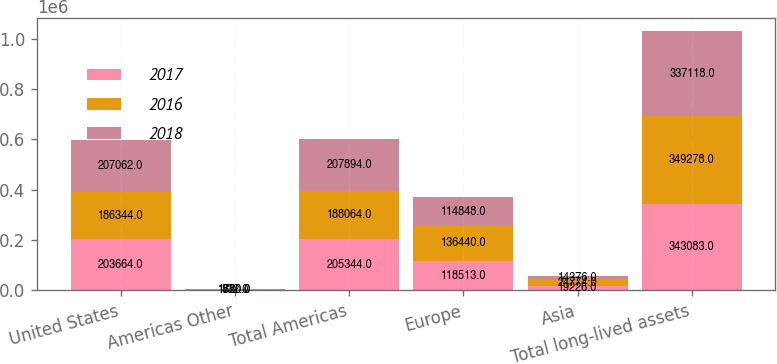Convert chart to OTSL. <chart><loc_0><loc_0><loc_500><loc_500><stacked_bar_chart><ecel><fcel>United States<fcel>Americas Other<fcel>Total Americas<fcel>Europe<fcel>Asia<fcel>Total long-lived assets<nl><fcel>2017<fcel>203664<fcel>1680<fcel>205344<fcel>118513<fcel>19226<fcel>343083<nl><fcel>2016<fcel>186344<fcel>1720<fcel>188064<fcel>136440<fcel>24774<fcel>349278<nl><fcel>2018<fcel>207062<fcel>832<fcel>207894<fcel>114848<fcel>14376<fcel>337118<nl></chart> 